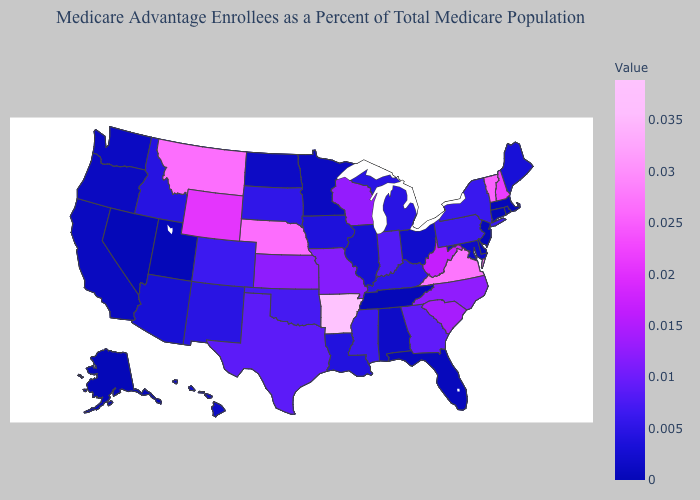Which states have the lowest value in the USA?
Concise answer only. Alaska, Connecticut, Delaware, Massachusetts, New Jersey, Nevada, Rhode Island, Tennessee, Utah. Which states have the highest value in the USA?
Keep it brief. Arkansas. Does North Dakota have the highest value in the USA?
Answer briefly. No. Among the states that border North Carolina , which have the lowest value?
Keep it brief. Tennessee. Does Oregon have the lowest value in the USA?
Answer briefly. No. 